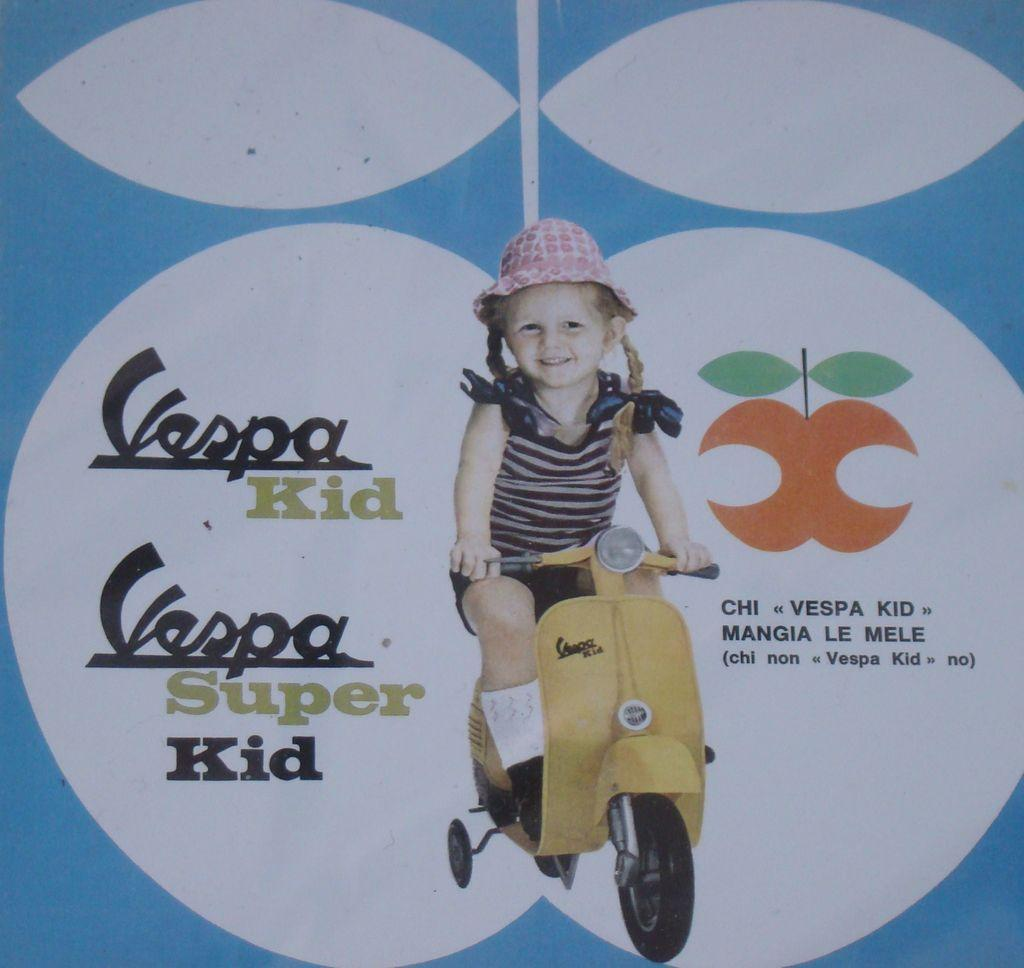What is featured in the image? There is a poster in the image. What is depicted on the poster? The poster depicts a child. What clothing items is the child wearing? The child is wearing clothes, shoes, socks, and a hat. What else can be seen on the poster? There is a vehicle visible in the poster, and there is text present as well. What type of pan is being used by the child in the image? There is no pan present in the image; the child is depicted wearing clothes, shoes, socks, and a hat, and there is a vehicle and text on the poster. 